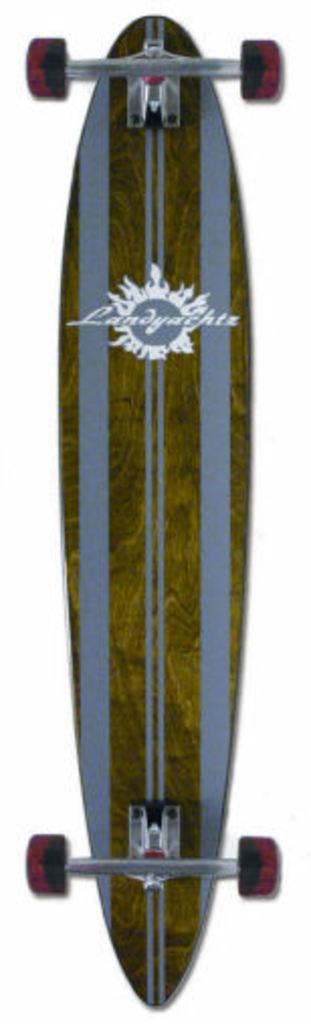How would you summarize this image in a sentence or two? In this picture we can see a skateboard and on the skateboard it is written something. Behind the skateboard there is a white background. 